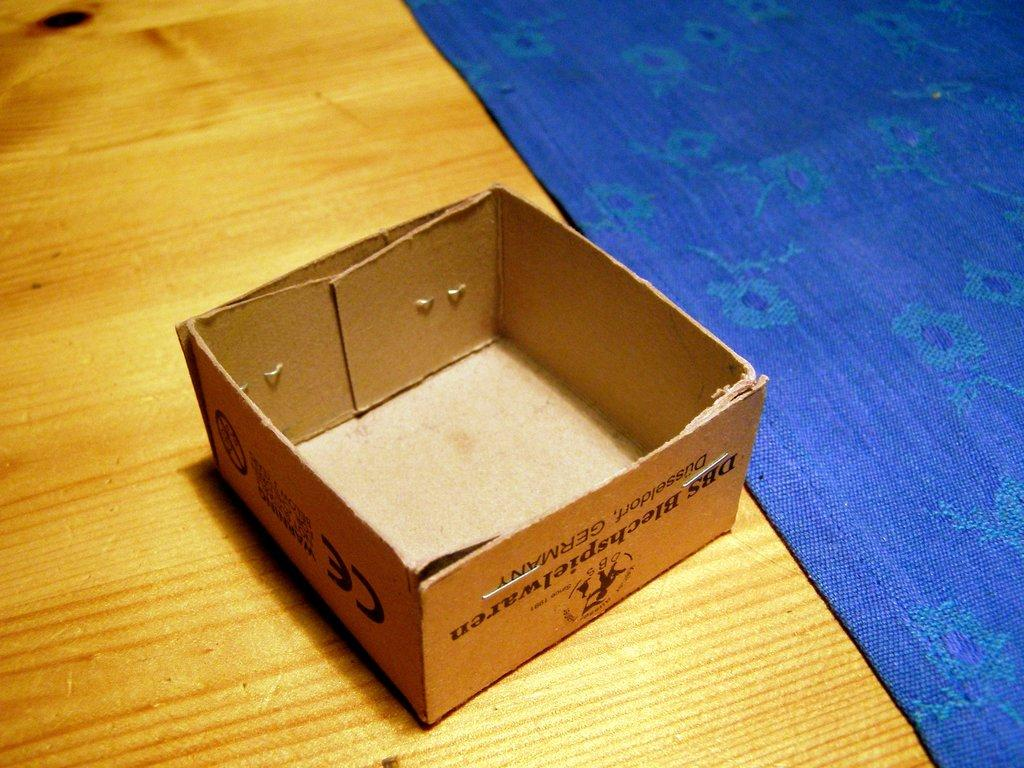<image>
Give a short and clear explanation of the subsequent image. Small cardboard box with the letters CE on it next to a blue rug. 